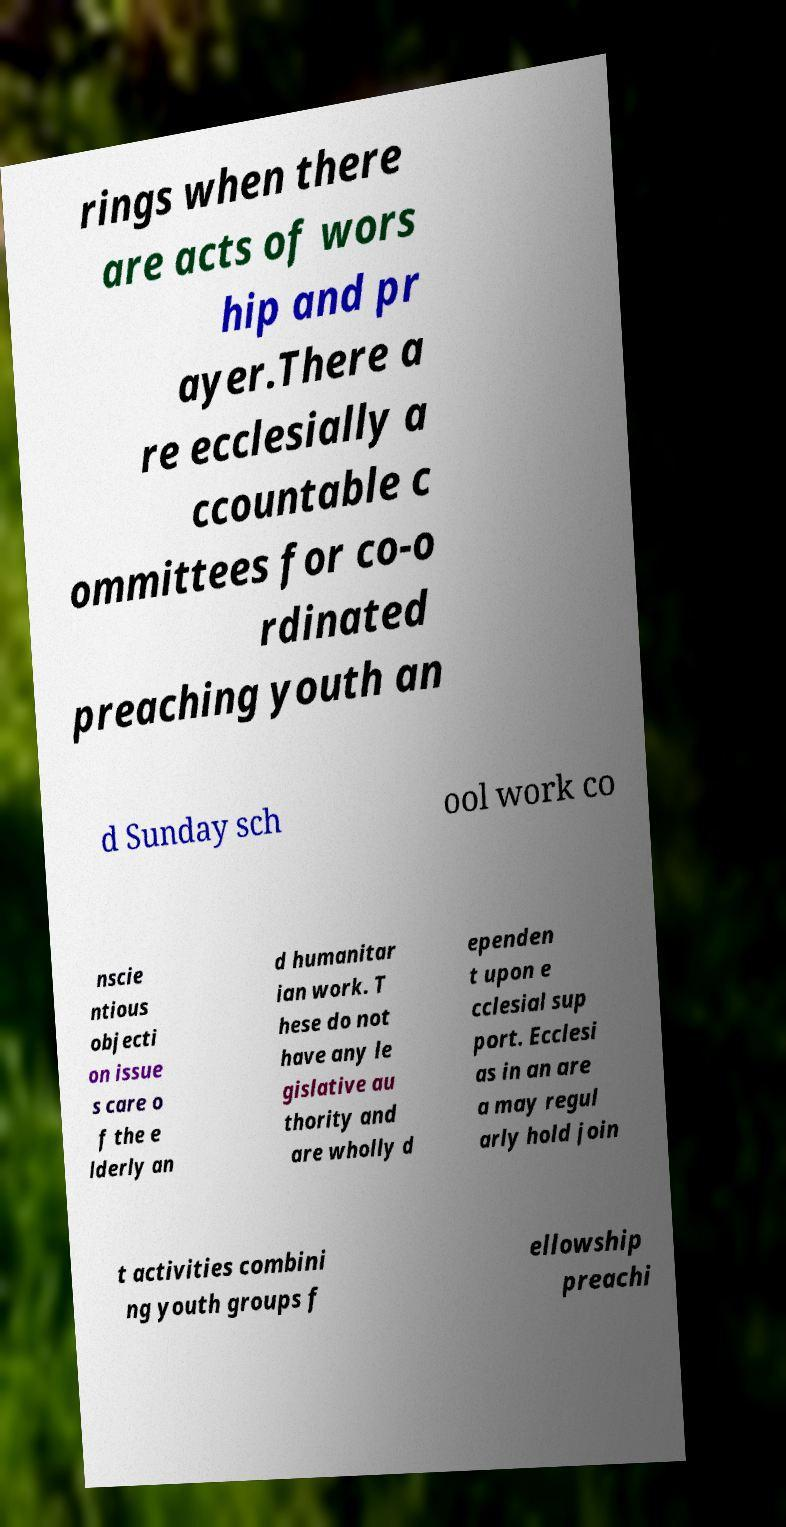Could you assist in decoding the text presented in this image and type it out clearly? rings when there are acts of wors hip and pr ayer.There a re ecclesially a ccountable c ommittees for co-o rdinated preaching youth an d Sunday sch ool work co nscie ntious objecti on issue s care o f the e lderly an d humanitar ian work. T hese do not have any le gislative au thority and are wholly d ependen t upon e cclesial sup port. Ecclesi as in an are a may regul arly hold join t activities combini ng youth groups f ellowship preachi 